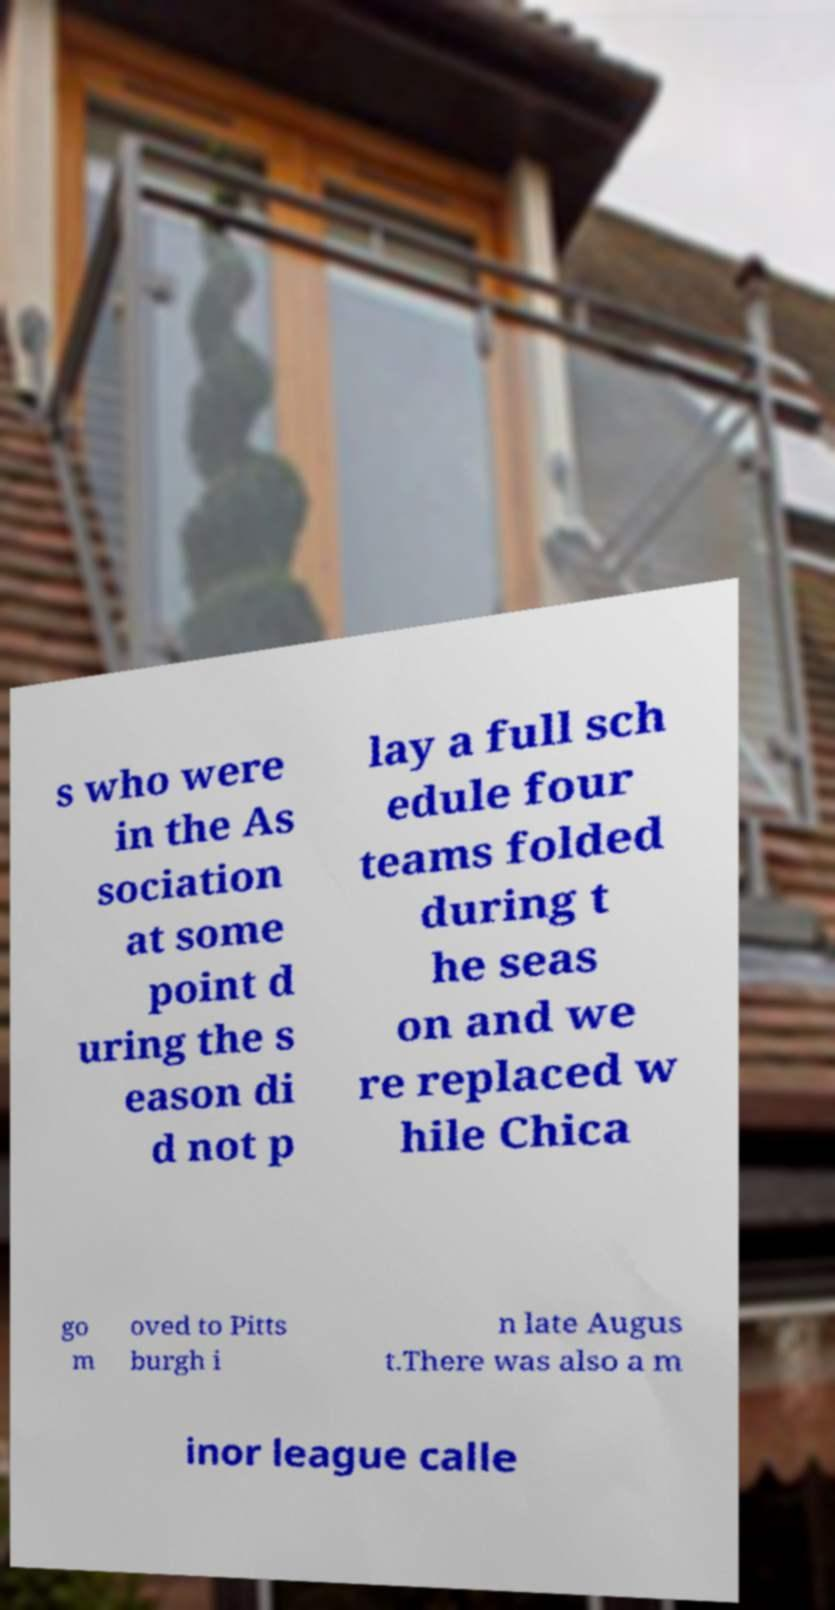Could you assist in decoding the text presented in this image and type it out clearly? s who were in the As sociation at some point d uring the s eason di d not p lay a full sch edule four teams folded during t he seas on and we re replaced w hile Chica go m oved to Pitts burgh i n late Augus t.There was also a m inor league calle 